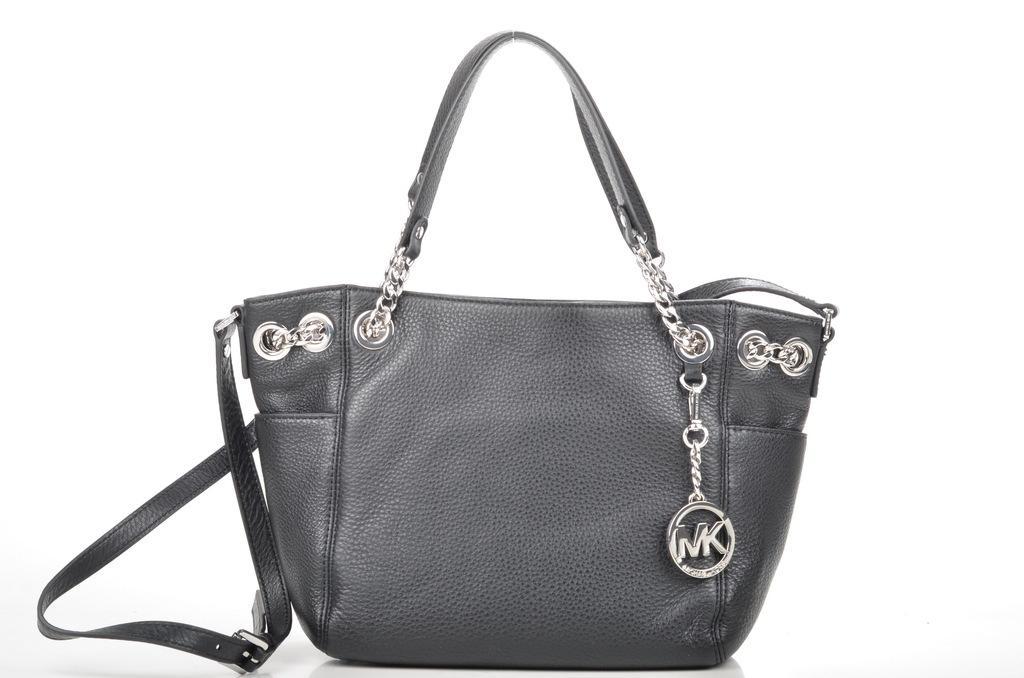Can you describe this image briefly? In this image we can see a handbag which is in ash color. 